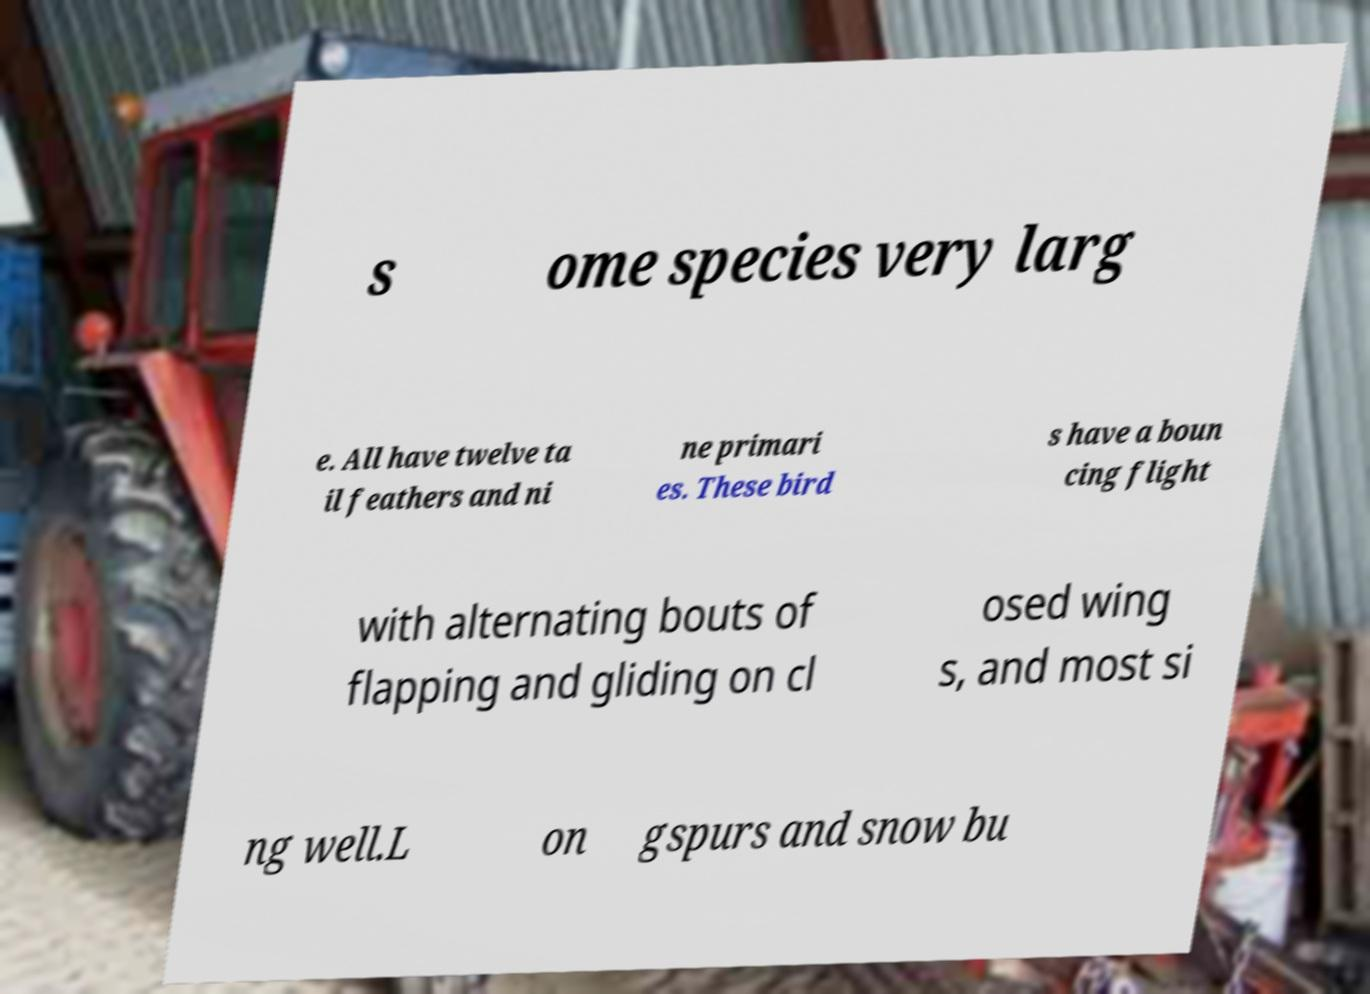What messages or text are displayed in this image? I need them in a readable, typed format. s ome species very larg e. All have twelve ta il feathers and ni ne primari es. These bird s have a boun cing flight with alternating bouts of flapping and gliding on cl osed wing s, and most si ng well.L on gspurs and snow bu 